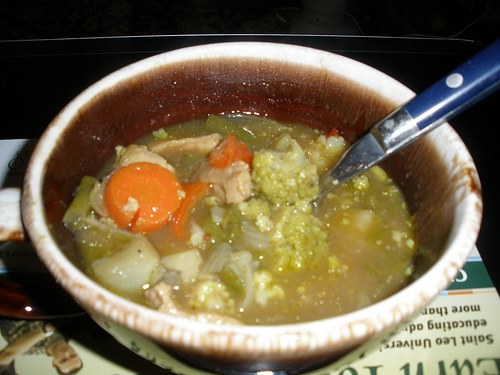What is the vegetable to the left of the onions in the center? To the left of the onions in the center of the image, you can see a carrot. 